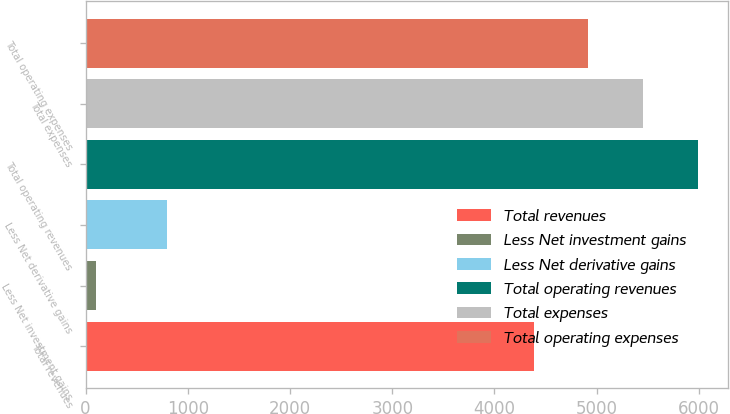Convert chart to OTSL. <chart><loc_0><loc_0><loc_500><loc_500><bar_chart><fcel>Total revenues<fcel>Less Net investment gains<fcel>Less Net derivative gains<fcel>Total operating revenues<fcel>Total expenses<fcel>Total operating expenses<nl><fcel>4383<fcel>105<fcel>798<fcel>5988<fcel>5453<fcel>4918<nl></chart> 